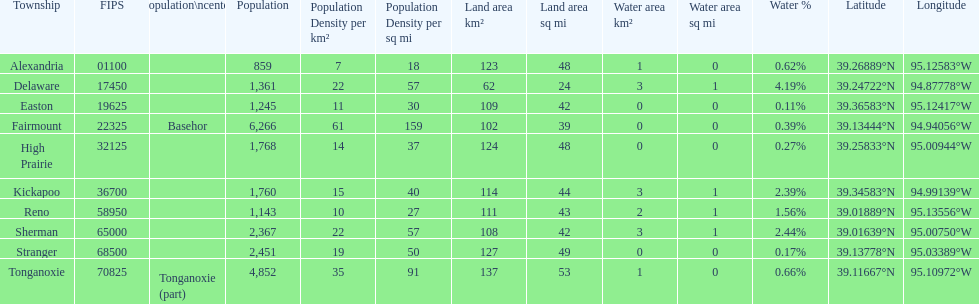How many townships have populations over 2,000? 4. 